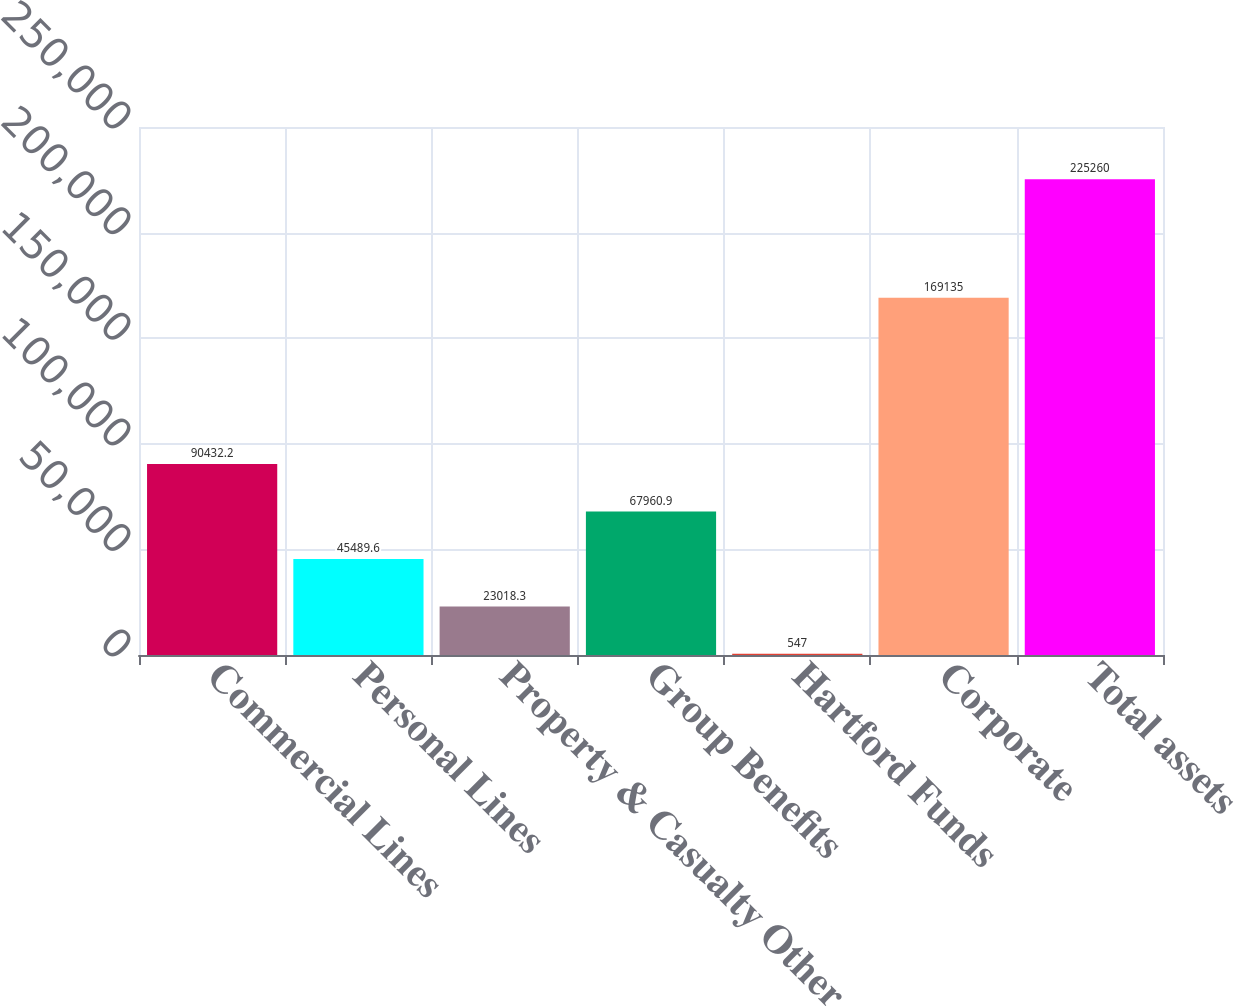<chart> <loc_0><loc_0><loc_500><loc_500><bar_chart><fcel>Commercial Lines<fcel>Personal Lines<fcel>Property & Casualty Other<fcel>Group Benefits<fcel>Hartford Funds<fcel>Corporate<fcel>Total assets<nl><fcel>90432.2<fcel>45489.6<fcel>23018.3<fcel>67960.9<fcel>547<fcel>169135<fcel>225260<nl></chart> 